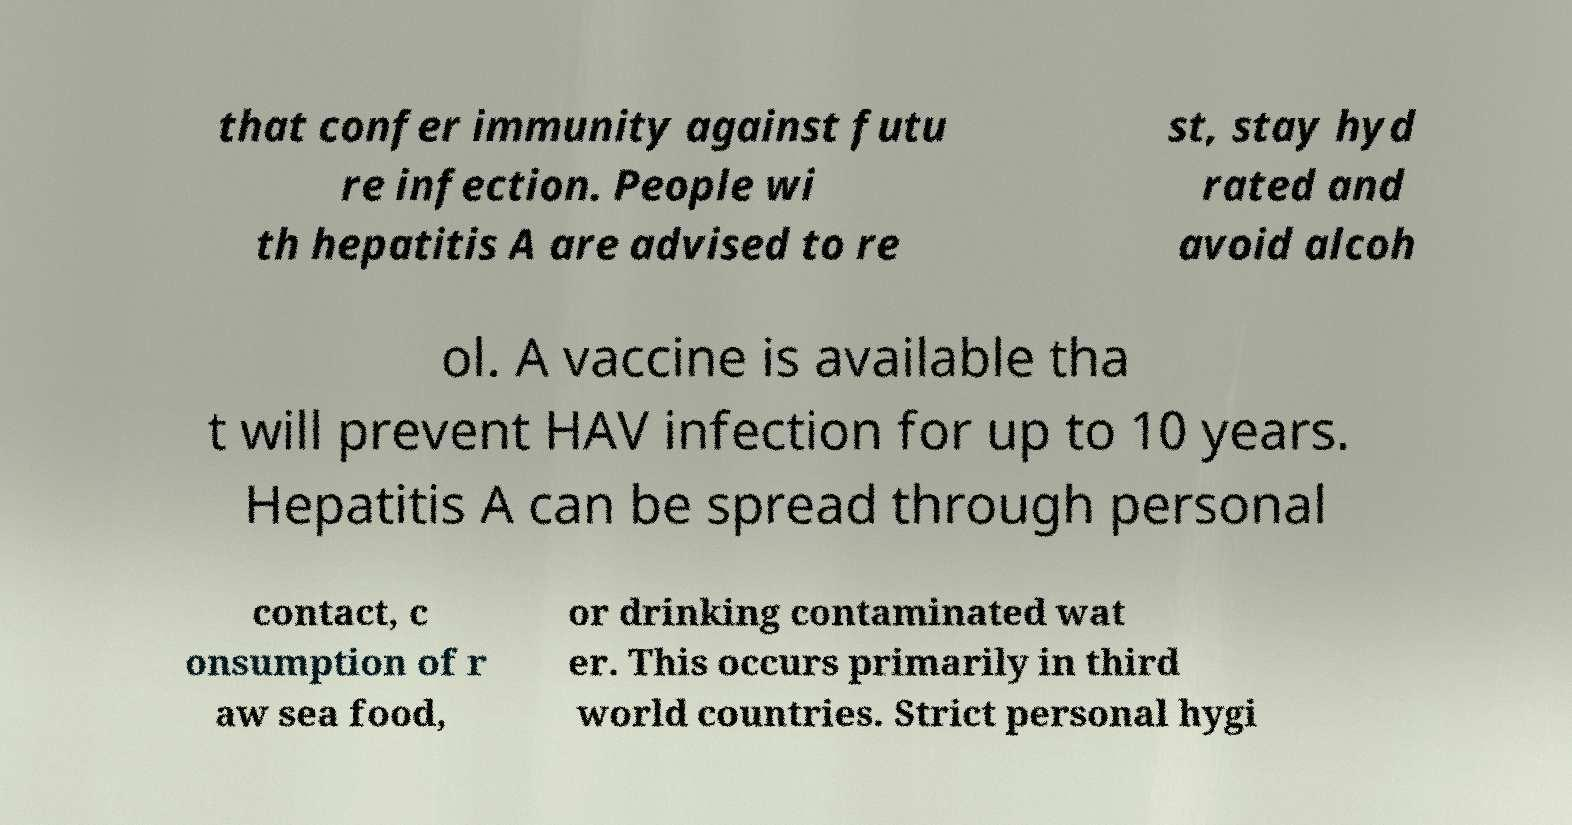For documentation purposes, I need the text within this image transcribed. Could you provide that? that confer immunity against futu re infection. People wi th hepatitis A are advised to re st, stay hyd rated and avoid alcoh ol. A vaccine is available tha t will prevent HAV infection for up to 10 years. Hepatitis A can be spread through personal contact, c onsumption of r aw sea food, or drinking contaminated wat er. This occurs primarily in third world countries. Strict personal hygi 